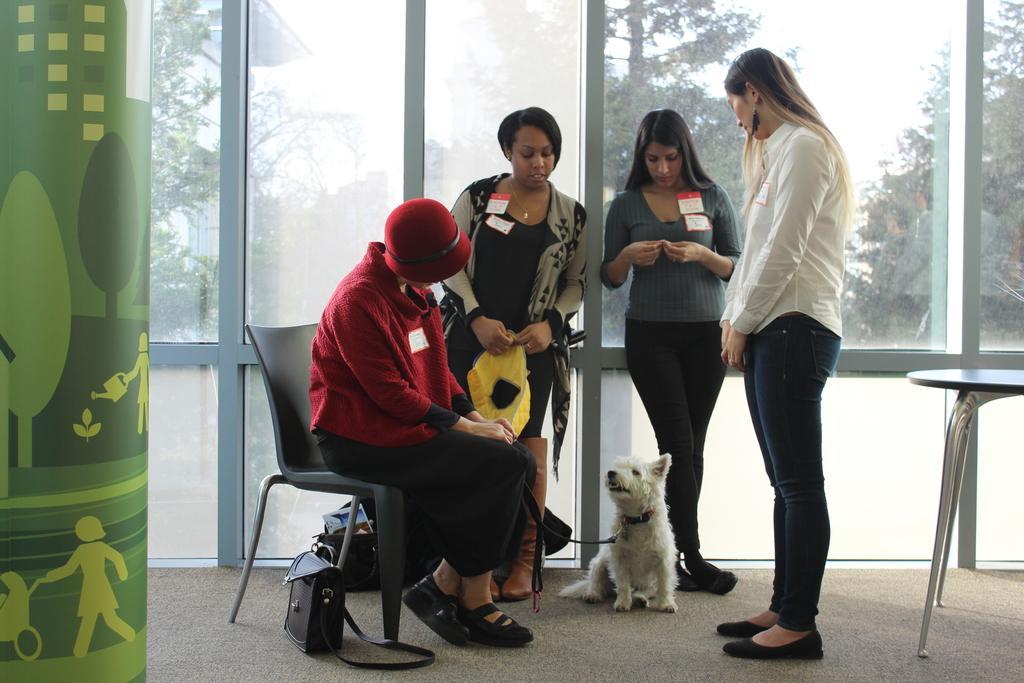Describe this image in one or two sentences. In this picture there is a person sitting on a chair and holding a dog with a leash. There is bag. There are three women standing. There is a table. There are few trees at the background. 